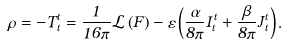Convert formula to latex. <formula><loc_0><loc_0><loc_500><loc_500>\rho = - T _ { t } ^ { t } = \frac { 1 } { 1 6 \pi } \mathcal { L } \left ( F \right ) - \varepsilon \left ( \frac { \alpha } { 8 \pi } I _ { t } ^ { t } + \frac { \beta } { 8 \pi } J _ { t } ^ { t } \right ) .</formula> 